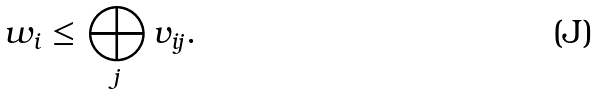Convert formula to latex. <formula><loc_0><loc_0><loc_500><loc_500>w _ { i } \leq \bigoplus _ { j } v _ { i j } .</formula> 